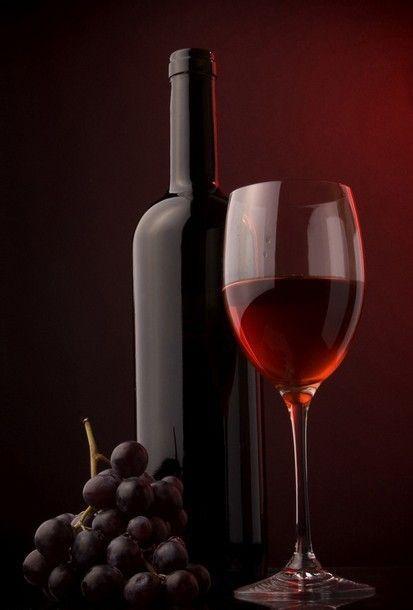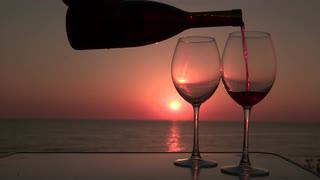The first image is the image on the left, the second image is the image on the right. Analyze the images presented: Is the assertion "In one image, red wine is being poured into a wine glass" valid? Answer yes or no. Yes. The first image is the image on the left, the second image is the image on the right. Evaluate the accuracy of this statement regarding the images: "At least one image contains a wine bottle, being poured into a glass, with a sunset in the background.". Is it true? Answer yes or no. Yes. 